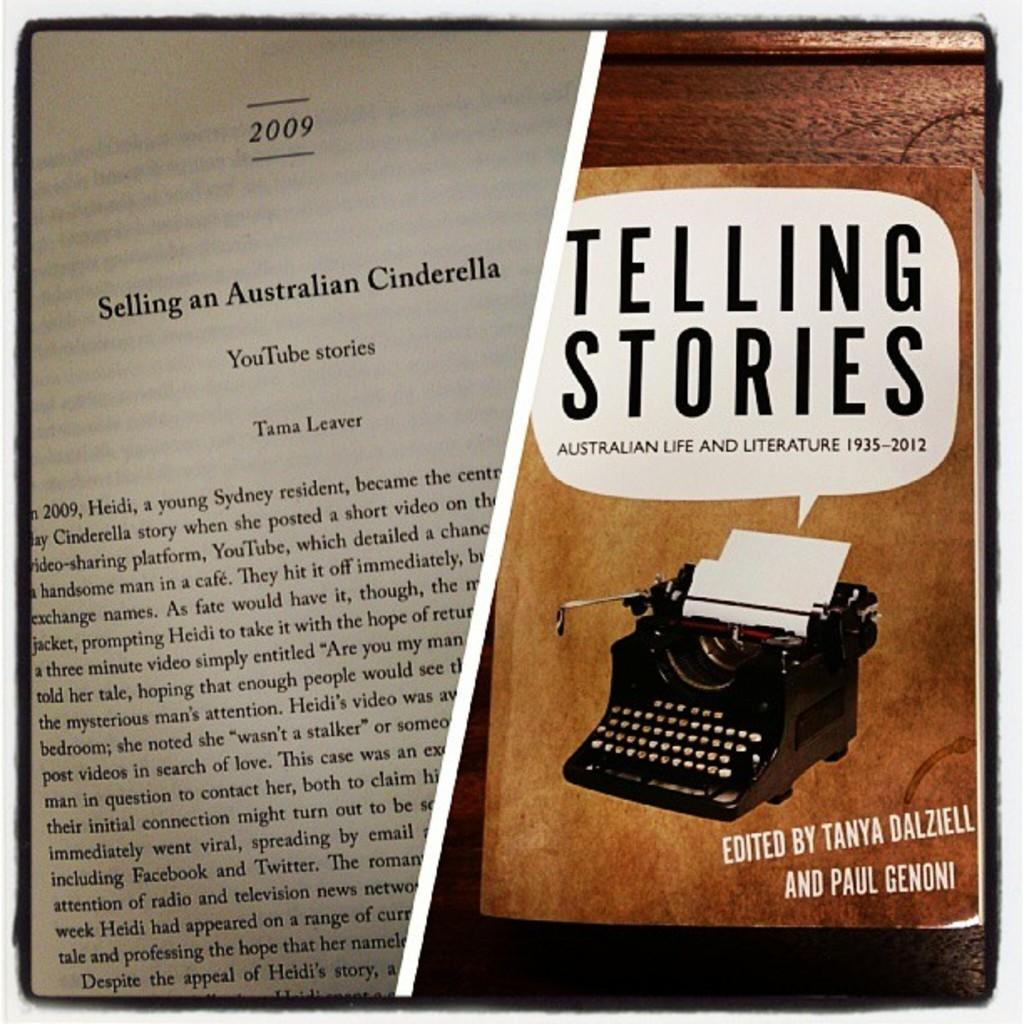<image>
Present a compact description of the photo's key features. A typewriter is on the cover of a book titled Telling Stories. 